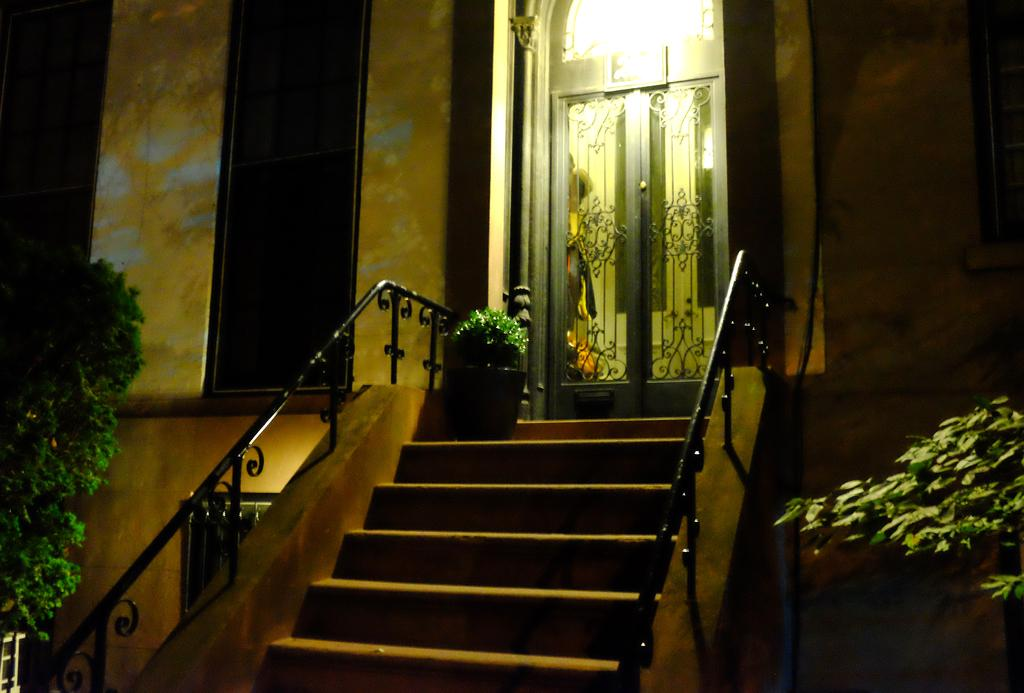What type of structure is present in the image? There is a building in the image. What feature of the building is visible in the image? There are doors visible in the image. Are there any architectural elements in the image? Yes, there are steps in the image. What type of natural elements can be seen in the image? There are plants in the image. What can be observed about the lighting in the image? There is light visible in the image. Where is the crown located in the image? There is no crown present in the image. What type of underwear can be seen on the plants in the image? There are no underwear items visible in the image, and plants do not wear underwear. 